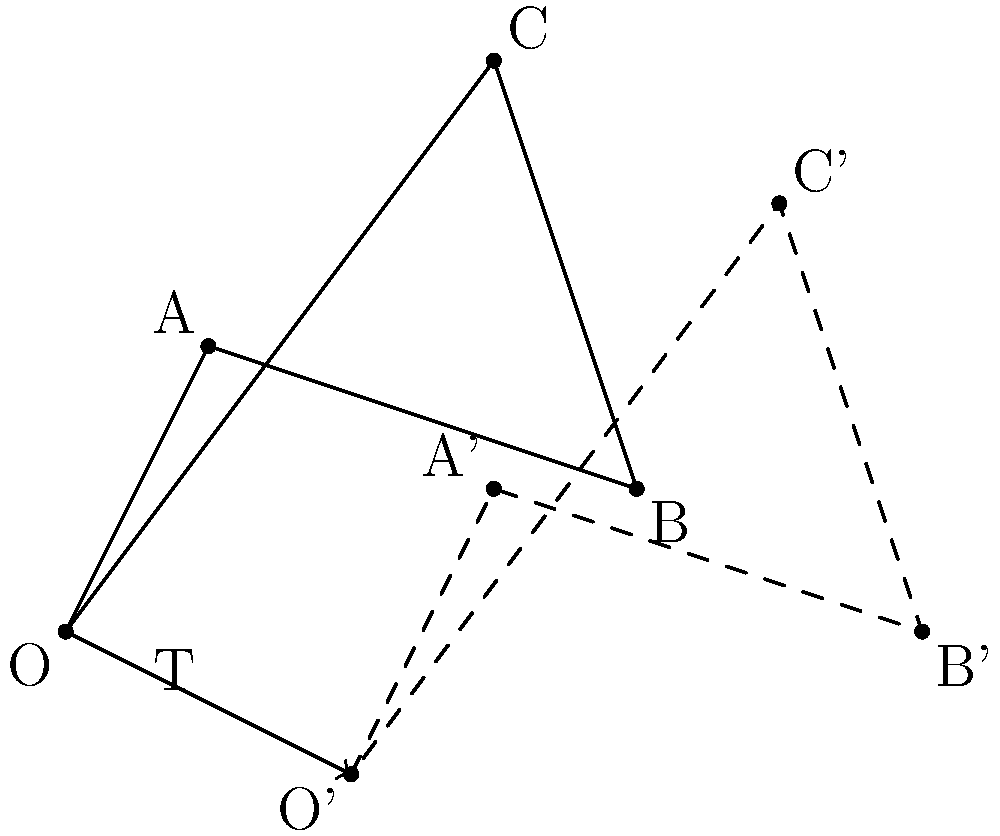For a fundraising contest, you need to translate the pitcher's mound to create optimal throwing angles. The original mound is represented by quadrilateral OABC. If the mound is translated by vector $\vec{T} = (2, -1)$, what are the coordinates of point C' in the new position? To find the coordinates of point C' after translation, we need to follow these steps:

1. Identify the original coordinates of point C:
   C = (3, 4)

2. Recall the translation vector:
   $\vec{T} = (2, -1)$

3. Apply the translation to point C:
   - Add the x-component of $\vec{T}$ to the x-coordinate of C
   - Add the y-component of $\vec{T}$ to the y-coordinate of C

   C' = (3 + 2, 4 + (-1))
      = (5, 3)

Therefore, the coordinates of point C' after translation are (5, 3).
Answer: (5, 3) 